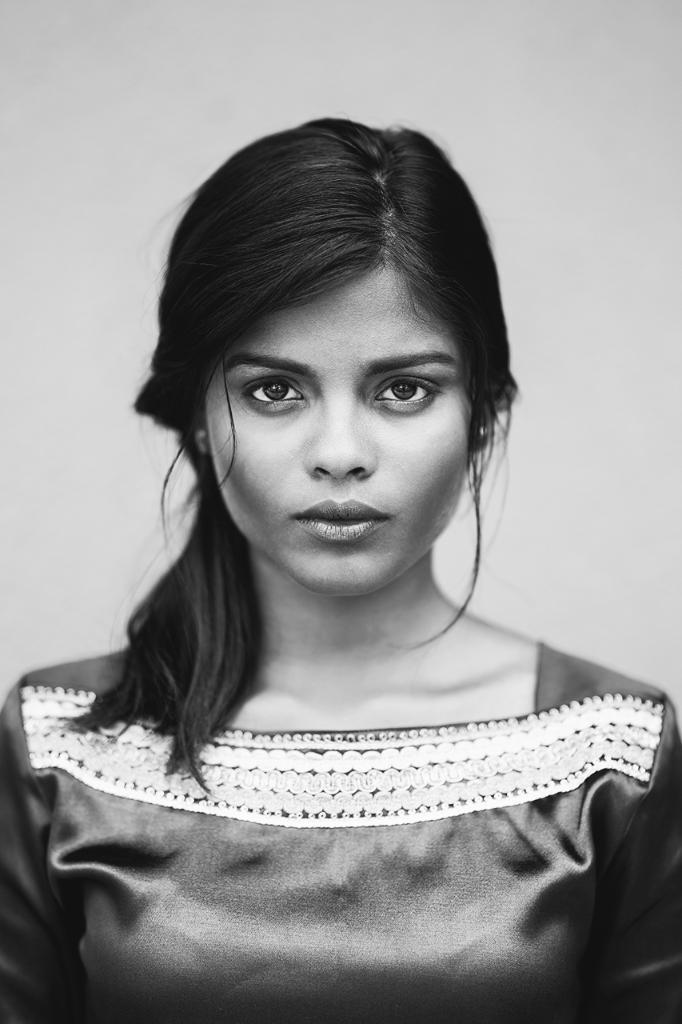What is the color scheme of the image? The image is black and white. What is the main subject of the image? There is a woman standing in the center of the image. What can be seen in the background of the image? There is a wall in the background of the image. How much profit did the woman make in the image? There is no information about profit in the image, as it is a black and white photograph of a woman standing in front of a wall. 